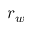<formula> <loc_0><loc_0><loc_500><loc_500>r _ { w }</formula> 